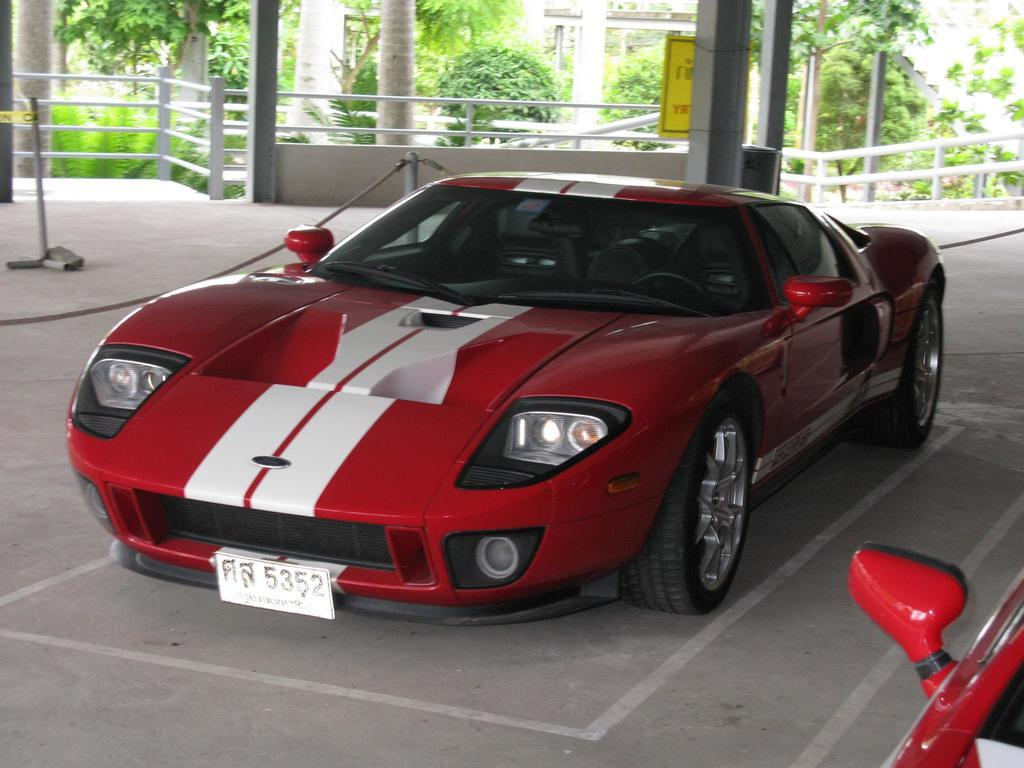What color is the car in the image? The car in the image is red. Where is the car located in the image? The car is in a parking lot. What can be seen in the background of the image? There is railing, trees, and buildings in the background of the image. What type of powder is being used to clean the car in the image? There is no powder or cleaning activity visible in the image; it only shows a red car in a parking lot. 